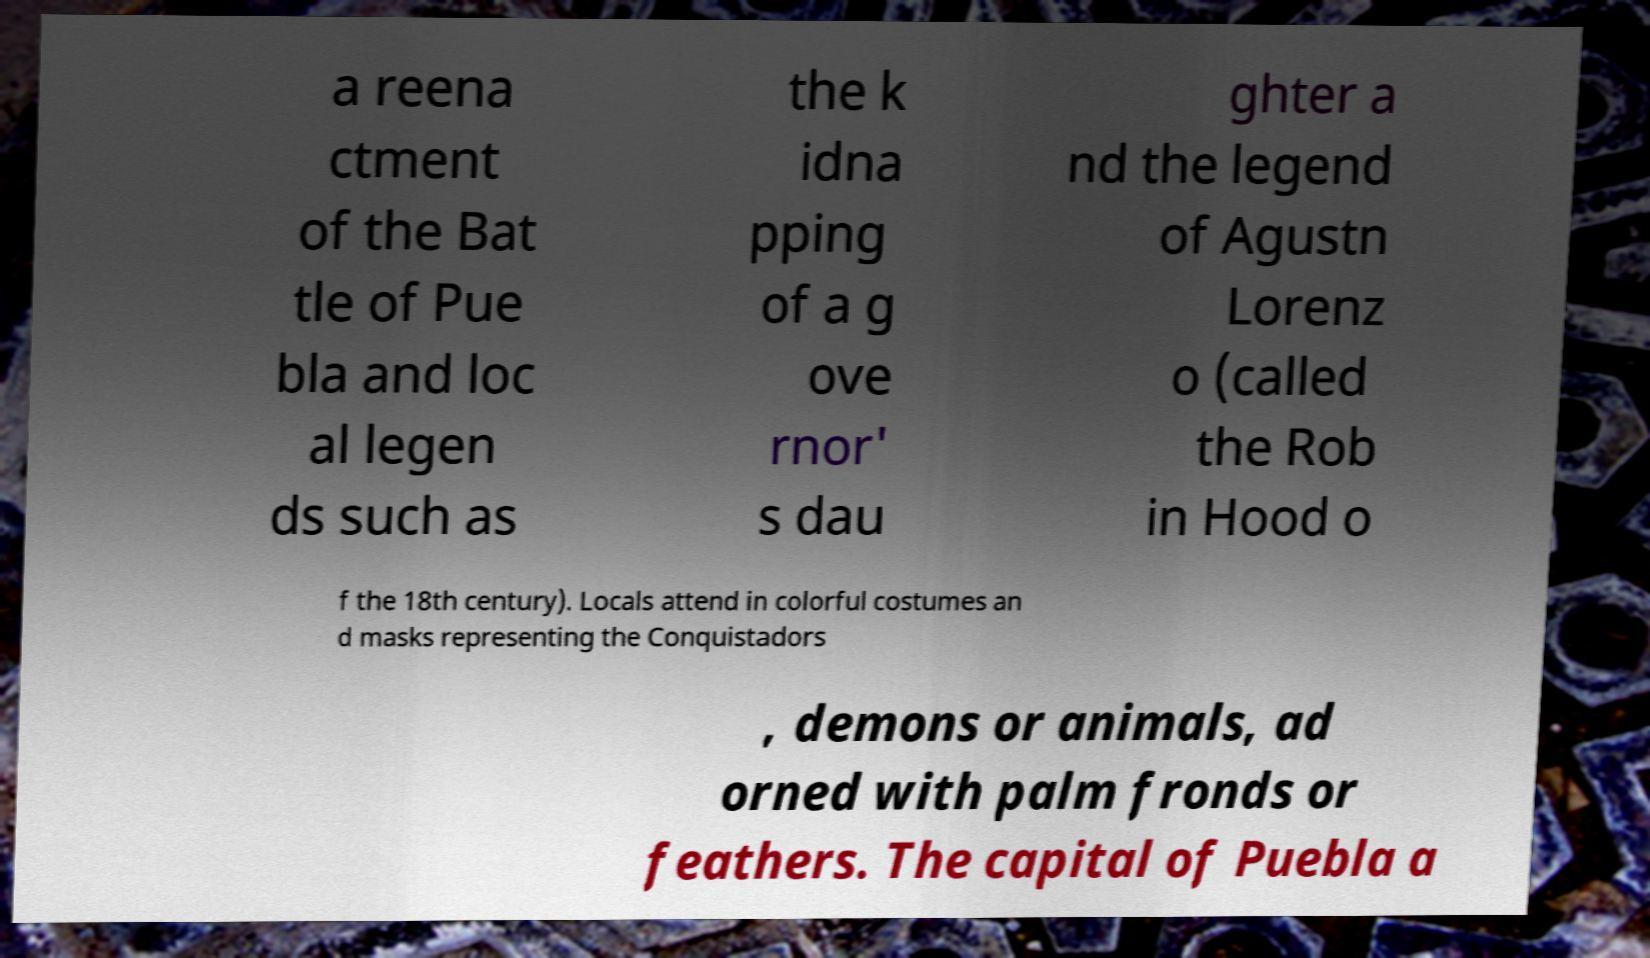Could you assist in decoding the text presented in this image and type it out clearly? a reena ctment of the Bat tle of Pue bla and loc al legen ds such as the k idna pping of a g ove rnor' s dau ghter a nd the legend of Agustn Lorenz o (called the Rob in Hood o f the 18th century). Locals attend in colorful costumes an d masks representing the Conquistadors , demons or animals, ad orned with palm fronds or feathers. The capital of Puebla a 